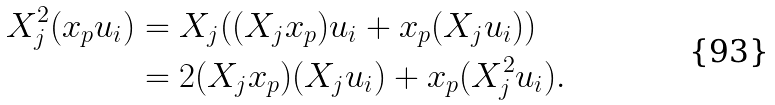Convert formula to latex. <formula><loc_0><loc_0><loc_500><loc_500>X _ { j } ^ { 2 } ( { x _ { p } } { u _ { i } } ) & = { X _ { j } } ( ( { X _ { j } } { x _ { p } } ) { u _ { i } } + { x _ { p } } ( { X _ { j } } { u _ { i } } ) ) \\ & = 2 ( { X _ { j } } { x _ { p } } ) ( { X _ { j } } { u _ { i } } ) + { x _ { p } } ( X _ { j } ^ { 2 } { u _ { i } } ) .</formula> 